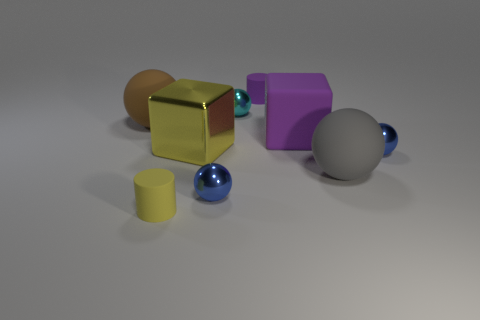What shape is the object that is the same color as the large metallic block?
Your answer should be compact. Cylinder. What number of brown objects are big spheres or small metal spheres?
Your answer should be compact. 1. There is a small metallic thing behind the big rubber object that is to the left of the rubber block; what shape is it?
Your answer should be compact. Sphere. There is a yellow metallic object that is the same size as the rubber block; what shape is it?
Ensure brevity in your answer.  Cube. Are there any tiny things that have the same color as the big metal cube?
Your answer should be very brief. Yes. Are there an equal number of small metal balls that are behind the yellow cylinder and big objects that are on the right side of the brown rubber sphere?
Your answer should be compact. Yes. There is a large yellow thing; is it the same shape as the blue thing that is right of the big gray rubber ball?
Your response must be concise. No. What number of other things are there of the same material as the purple cylinder
Make the answer very short. 4. There is a large gray matte thing; are there any tiny cyan metallic objects in front of it?
Your answer should be compact. No. There is a yellow rubber thing; does it have the same size as the matte thing on the left side of the small yellow thing?
Keep it short and to the point. No. 